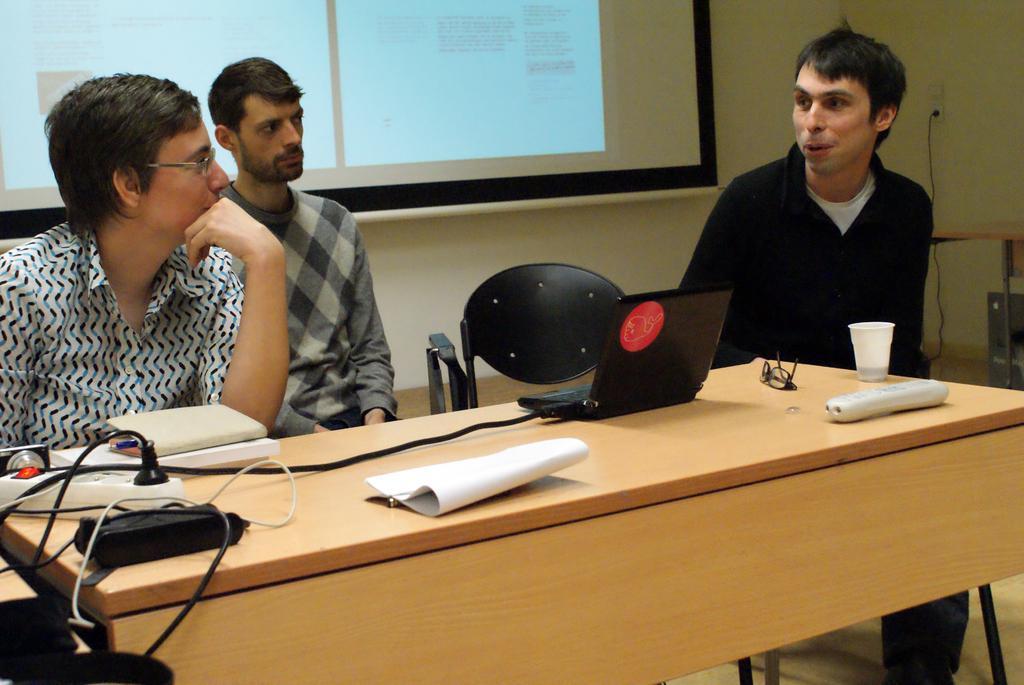In one or two sentences, can you explain what this image depicts? In this image i can see 3 persons sitting on chairs with a table in front of them. On the table i can see extension box with wires and a laptop and a remote, a cup and glasses. On the background i can see wall and a projection screen. 